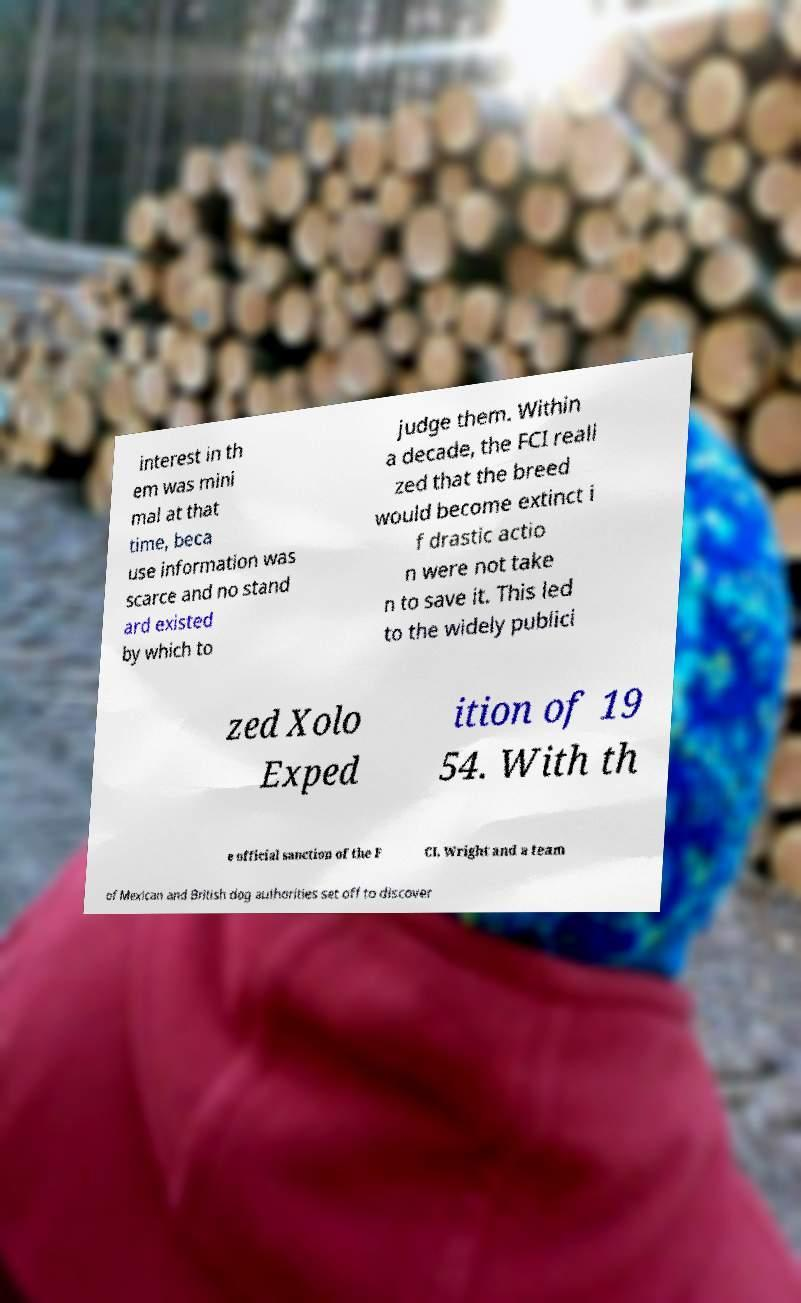Could you assist in decoding the text presented in this image and type it out clearly? interest in th em was mini mal at that time, beca use information was scarce and no stand ard existed by which to judge them. Within a decade, the FCI reali zed that the breed would become extinct i f drastic actio n were not take n to save it. This led to the widely publici zed Xolo Exped ition of 19 54. With th e official sanction of the F CI, Wright and a team of Mexican and British dog authorities set off to discover 